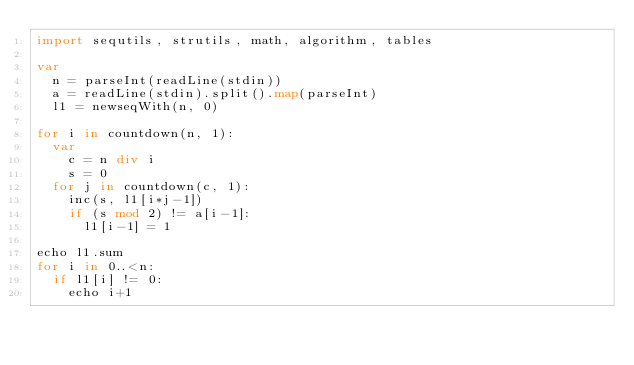Convert code to text. <code><loc_0><loc_0><loc_500><loc_500><_Nim_>import sequtils, strutils, math, algorithm, tables

var
  n = parseInt(readLine(stdin))
  a = readLine(stdin).split().map(parseInt)
  l1 = newseqWith(n, 0)
  
for i in countdown(n, 1):
  var
    c = n div i
    s = 0
  for j in countdown(c, 1):
    inc(s, l1[i*j-1])
    if (s mod 2) != a[i-1]:
      l1[i-1] = 1
        
echo l1.sum
for i in 0..<n:
  if l1[i] != 0:
    echo i+1
</code> 